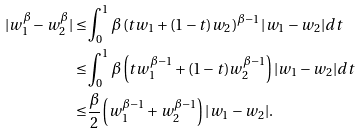Convert formula to latex. <formula><loc_0><loc_0><loc_500><loc_500>| w _ { 1 } ^ { \beta } - w _ { 2 } ^ { \beta } | \leq & \int _ { 0 } ^ { 1 } \beta \left ( t w _ { 1 } + ( 1 - t ) w _ { 2 } \right ) ^ { \beta - 1 } | w _ { 1 } - w _ { 2 } | d t \\ \leq & \int _ { 0 } ^ { 1 } \beta \left ( t w _ { 1 } ^ { \beta - 1 } + ( 1 - t ) w _ { 2 } ^ { \beta - 1 } \right ) | w _ { 1 } - w _ { 2 } | d t \\ \leq & \frac { \beta } { 2 } \left ( w _ { 1 } ^ { \beta - 1 } + w _ { 2 } ^ { \beta - 1 } \right ) | w _ { 1 } - w _ { 2 } | .</formula> 